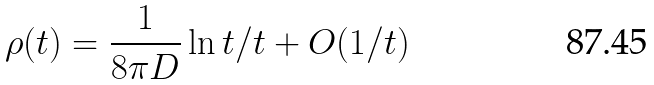<formula> <loc_0><loc_0><loc_500><loc_500>\rho ( t ) = \frac { 1 } { 8 \pi D } \ln t / t + O ( 1 / t )</formula> 